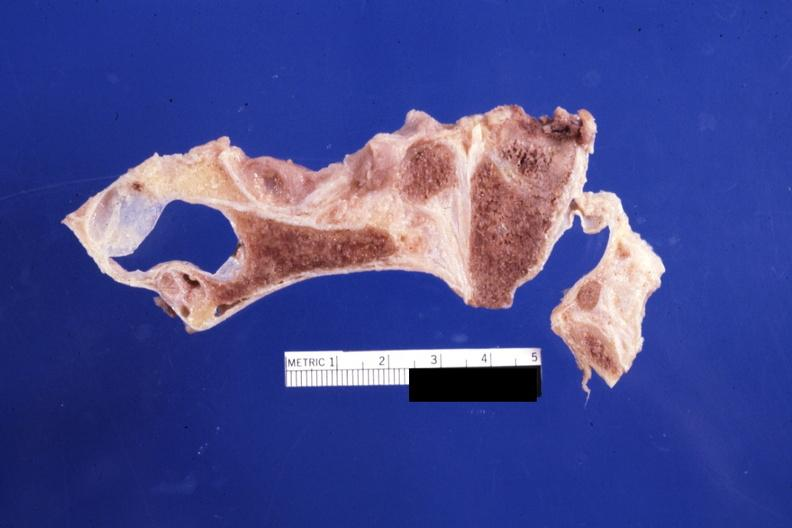what is present?
Answer the question using a single word or phrase. Bone, calvarium 